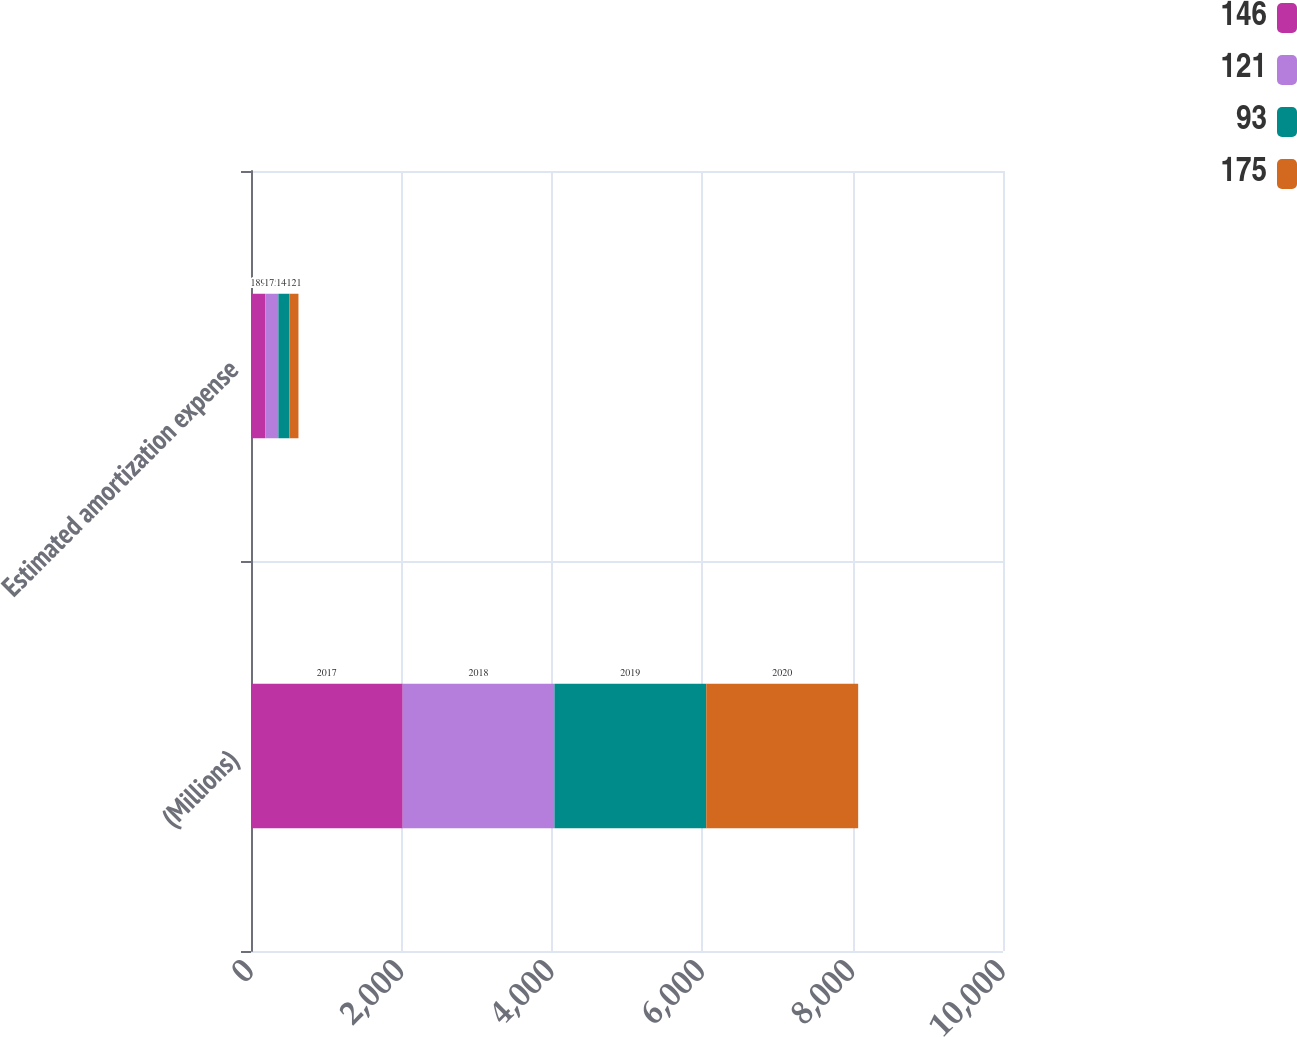Convert chart to OTSL. <chart><loc_0><loc_0><loc_500><loc_500><stacked_bar_chart><ecel><fcel>(Millions)<fcel>Estimated amortization expense<nl><fcel>146<fcel>2017<fcel>189<nl><fcel>121<fcel>2018<fcel>175<nl><fcel>93<fcel>2019<fcel>146<nl><fcel>175<fcel>2020<fcel>121<nl></chart> 